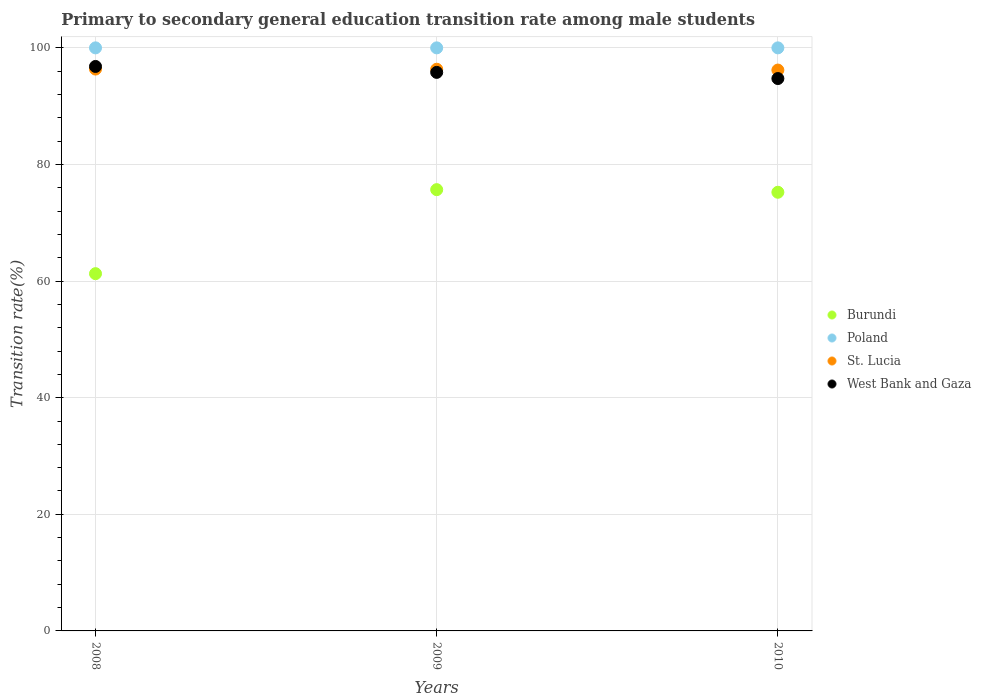Is the number of dotlines equal to the number of legend labels?
Your answer should be compact. Yes. What is the transition rate in West Bank and Gaza in 2008?
Offer a very short reply. 96.81. Across all years, what is the maximum transition rate in Burundi?
Offer a terse response. 75.68. Across all years, what is the minimum transition rate in Burundi?
Give a very brief answer. 61.27. In which year was the transition rate in Burundi minimum?
Offer a terse response. 2008. What is the total transition rate in Burundi in the graph?
Give a very brief answer. 212.19. What is the difference between the transition rate in Burundi in 2008 and that in 2009?
Provide a short and direct response. -14.41. What is the difference between the transition rate in West Bank and Gaza in 2008 and the transition rate in St. Lucia in 2009?
Your answer should be compact. 0.48. What is the average transition rate in St. Lucia per year?
Provide a succinct answer. 96.3. In the year 2008, what is the difference between the transition rate in St. Lucia and transition rate in Burundi?
Make the answer very short. 35.09. In how many years, is the transition rate in St. Lucia greater than 60 %?
Ensure brevity in your answer.  3. What is the ratio of the transition rate in St. Lucia in 2008 to that in 2010?
Provide a succinct answer. 1. Is the difference between the transition rate in St. Lucia in 2008 and 2010 greater than the difference between the transition rate in Burundi in 2008 and 2010?
Provide a succinct answer. Yes. What is the difference between the highest and the second highest transition rate in St. Lucia?
Your answer should be very brief. 0.03. What is the difference between the highest and the lowest transition rate in Poland?
Provide a short and direct response. 0. In how many years, is the transition rate in West Bank and Gaza greater than the average transition rate in West Bank and Gaza taken over all years?
Offer a very short reply. 2. Is it the case that in every year, the sum of the transition rate in Burundi and transition rate in Poland  is greater than the sum of transition rate in West Bank and Gaza and transition rate in St. Lucia?
Keep it short and to the point. Yes. Does the graph contain any zero values?
Your answer should be compact. No. Does the graph contain grids?
Ensure brevity in your answer.  Yes. How many legend labels are there?
Your response must be concise. 4. What is the title of the graph?
Your answer should be very brief. Primary to secondary general education transition rate among male students. Does "Paraguay" appear as one of the legend labels in the graph?
Give a very brief answer. No. What is the label or title of the Y-axis?
Provide a succinct answer. Transition rate(%). What is the Transition rate(%) in Burundi in 2008?
Provide a short and direct response. 61.27. What is the Transition rate(%) of Poland in 2008?
Ensure brevity in your answer.  100. What is the Transition rate(%) in St. Lucia in 2008?
Provide a short and direct response. 96.37. What is the Transition rate(%) of West Bank and Gaza in 2008?
Your answer should be compact. 96.81. What is the Transition rate(%) in Burundi in 2009?
Your answer should be very brief. 75.68. What is the Transition rate(%) in Poland in 2009?
Provide a succinct answer. 100. What is the Transition rate(%) of St. Lucia in 2009?
Your answer should be compact. 96.33. What is the Transition rate(%) of West Bank and Gaza in 2009?
Provide a short and direct response. 95.8. What is the Transition rate(%) of Burundi in 2010?
Keep it short and to the point. 75.24. What is the Transition rate(%) in St. Lucia in 2010?
Keep it short and to the point. 96.19. What is the Transition rate(%) of West Bank and Gaza in 2010?
Keep it short and to the point. 94.74. Across all years, what is the maximum Transition rate(%) in Burundi?
Provide a short and direct response. 75.68. Across all years, what is the maximum Transition rate(%) of St. Lucia?
Your answer should be compact. 96.37. Across all years, what is the maximum Transition rate(%) of West Bank and Gaza?
Give a very brief answer. 96.81. Across all years, what is the minimum Transition rate(%) of Burundi?
Offer a very short reply. 61.27. Across all years, what is the minimum Transition rate(%) in St. Lucia?
Your response must be concise. 96.19. Across all years, what is the minimum Transition rate(%) in West Bank and Gaza?
Make the answer very short. 94.74. What is the total Transition rate(%) in Burundi in the graph?
Your answer should be compact. 212.19. What is the total Transition rate(%) in Poland in the graph?
Offer a very short reply. 300. What is the total Transition rate(%) in St. Lucia in the graph?
Ensure brevity in your answer.  288.89. What is the total Transition rate(%) in West Bank and Gaza in the graph?
Your answer should be compact. 287.34. What is the difference between the Transition rate(%) of Burundi in 2008 and that in 2009?
Your response must be concise. -14.41. What is the difference between the Transition rate(%) in St. Lucia in 2008 and that in 2009?
Provide a succinct answer. 0.03. What is the difference between the Transition rate(%) of West Bank and Gaza in 2008 and that in 2009?
Provide a short and direct response. 1.02. What is the difference between the Transition rate(%) of Burundi in 2008 and that in 2010?
Offer a very short reply. -13.96. What is the difference between the Transition rate(%) of St. Lucia in 2008 and that in 2010?
Your response must be concise. 0.17. What is the difference between the Transition rate(%) of West Bank and Gaza in 2008 and that in 2010?
Your response must be concise. 2.07. What is the difference between the Transition rate(%) of Burundi in 2009 and that in 2010?
Offer a terse response. 0.45. What is the difference between the Transition rate(%) of St. Lucia in 2009 and that in 2010?
Make the answer very short. 0.14. What is the difference between the Transition rate(%) of West Bank and Gaza in 2009 and that in 2010?
Provide a short and direct response. 1.06. What is the difference between the Transition rate(%) of Burundi in 2008 and the Transition rate(%) of Poland in 2009?
Provide a short and direct response. -38.73. What is the difference between the Transition rate(%) of Burundi in 2008 and the Transition rate(%) of St. Lucia in 2009?
Keep it short and to the point. -35.06. What is the difference between the Transition rate(%) in Burundi in 2008 and the Transition rate(%) in West Bank and Gaza in 2009?
Provide a short and direct response. -34.52. What is the difference between the Transition rate(%) of Poland in 2008 and the Transition rate(%) of St. Lucia in 2009?
Offer a terse response. 3.67. What is the difference between the Transition rate(%) in Poland in 2008 and the Transition rate(%) in West Bank and Gaza in 2009?
Provide a succinct answer. 4.2. What is the difference between the Transition rate(%) of St. Lucia in 2008 and the Transition rate(%) of West Bank and Gaza in 2009?
Your answer should be very brief. 0.57. What is the difference between the Transition rate(%) in Burundi in 2008 and the Transition rate(%) in Poland in 2010?
Keep it short and to the point. -38.73. What is the difference between the Transition rate(%) of Burundi in 2008 and the Transition rate(%) of St. Lucia in 2010?
Offer a very short reply. -34.92. What is the difference between the Transition rate(%) of Burundi in 2008 and the Transition rate(%) of West Bank and Gaza in 2010?
Make the answer very short. -33.46. What is the difference between the Transition rate(%) of Poland in 2008 and the Transition rate(%) of St. Lucia in 2010?
Your answer should be very brief. 3.81. What is the difference between the Transition rate(%) of Poland in 2008 and the Transition rate(%) of West Bank and Gaza in 2010?
Give a very brief answer. 5.26. What is the difference between the Transition rate(%) in St. Lucia in 2008 and the Transition rate(%) in West Bank and Gaza in 2010?
Provide a short and direct response. 1.63. What is the difference between the Transition rate(%) in Burundi in 2009 and the Transition rate(%) in Poland in 2010?
Your response must be concise. -24.32. What is the difference between the Transition rate(%) of Burundi in 2009 and the Transition rate(%) of St. Lucia in 2010?
Provide a short and direct response. -20.51. What is the difference between the Transition rate(%) of Burundi in 2009 and the Transition rate(%) of West Bank and Gaza in 2010?
Keep it short and to the point. -19.06. What is the difference between the Transition rate(%) in Poland in 2009 and the Transition rate(%) in St. Lucia in 2010?
Ensure brevity in your answer.  3.81. What is the difference between the Transition rate(%) in Poland in 2009 and the Transition rate(%) in West Bank and Gaza in 2010?
Ensure brevity in your answer.  5.26. What is the difference between the Transition rate(%) in St. Lucia in 2009 and the Transition rate(%) in West Bank and Gaza in 2010?
Your response must be concise. 1.6. What is the average Transition rate(%) in Burundi per year?
Offer a very short reply. 70.73. What is the average Transition rate(%) in Poland per year?
Your response must be concise. 100. What is the average Transition rate(%) in St. Lucia per year?
Offer a very short reply. 96.3. What is the average Transition rate(%) of West Bank and Gaza per year?
Your answer should be very brief. 95.78. In the year 2008, what is the difference between the Transition rate(%) of Burundi and Transition rate(%) of Poland?
Your answer should be compact. -38.73. In the year 2008, what is the difference between the Transition rate(%) in Burundi and Transition rate(%) in St. Lucia?
Offer a terse response. -35.09. In the year 2008, what is the difference between the Transition rate(%) in Burundi and Transition rate(%) in West Bank and Gaza?
Your response must be concise. -35.54. In the year 2008, what is the difference between the Transition rate(%) of Poland and Transition rate(%) of St. Lucia?
Your response must be concise. 3.63. In the year 2008, what is the difference between the Transition rate(%) in Poland and Transition rate(%) in West Bank and Gaza?
Make the answer very short. 3.19. In the year 2008, what is the difference between the Transition rate(%) of St. Lucia and Transition rate(%) of West Bank and Gaza?
Provide a succinct answer. -0.45. In the year 2009, what is the difference between the Transition rate(%) in Burundi and Transition rate(%) in Poland?
Offer a terse response. -24.32. In the year 2009, what is the difference between the Transition rate(%) in Burundi and Transition rate(%) in St. Lucia?
Offer a very short reply. -20.65. In the year 2009, what is the difference between the Transition rate(%) of Burundi and Transition rate(%) of West Bank and Gaza?
Your response must be concise. -20.11. In the year 2009, what is the difference between the Transition rate(%) in Poland and Transition rate(%) in St. Lucia?
Make the answer very short. 3.67. In the year 2009, what is the difference between the Transition rate(%) of Poland and Transition rate(%) of West Bank and Gaza?
Provide a succinct answer. 4.2. In the year 2009, what is the difference between the Transition rate(%) in St. Lucia and Transition rate(%) in West Bank and Gaza?
Make the answer very short. 0.54. In the year 2010, what is the difference between the Transition rate(%) in Burundi and Transition rate(%) in Poland?
Provide a succinct answer. -24.76. In the year 2010, what is the difference between the Transition rate(%) in Burundi and Transition rate(%) in St. Lucia?
Give a very brief answer. -20.96. In the year 2010, what is the difference between the Transition rate(%) of Burundi and Transition rate(%) of West Bank and Gaza?
Ensure brevity in your answer.  -19.5. In the year 2010, what is the difference between the Transition rate(%) in Poland and Transition rate(%) in St. Lucia?
Provide a succinct answer. 3.81. In the year 2010, what is the difference between the Transition rate(%) in Poland and Transition rate(%) in West Bank and Gaza?
Offer a terse response. 5.26. In the year 2010, what is the difference between the Transition rate(%) in St. Lucia and Transition rate(%) in West Bank and Gaza?
Offer a very short reply. 1.46. What is the ratio of the Transition rate(%) in Burundi in 2008 to that in 2009?
Make the answer very short. 0.81. What is the ratio of the Transition rate(%) of Poland in 2008 to that in 2009?
Make the answer very short. 1. What is the ratio of the Transition rate(%) in St. Lucia in 2008 to that in 2009?
Ensure brevity in your answer.  1. What is the ratio of the Transition rate(%) of West Bank and Gaza in 2008 to that in 2009?
Provide a short and direct response. 1.01. What is the ratio of the Transition rate(%) in Burundi in 2008 to that in 2010?
Offer a very short reply. 0.81. What is the ratio of the Transition rate(%) in West Bank and Gaza in 2008 to that in 2010?
Offer a terse response. 1.02. What is the ratio of the Transition rate(%) in Burundi in 2009 to that in 2010?
Your answer should be very brief. 1.01. What is the ratio of the Transition rate(%) in West Bank and Gaza in 2009 to that in 2010?
Keep it short and to the point. 1.01. What is the difference between the highest and the second highest Transition rate(%) of Burundi?
Make the answer very short. 0.45. What is the difference between the highest and the second highest Transition rate(%) of St. Lucia?
Provide a succinct answer. 0.03. What is the difference between the highest and the second highest Transition rate(%) of West Bank and Gaza?
Offer a terse response. 1.02. What is the difference between the highest and the lowest Transition rate(%) of Burundi?
Make the answer very short. 14.41. What is the difference between the highest and the lowest Transition rate(%) in Poland?
Provide a succinct answer. 0. What is the difference between the highest and the lowest Transition rate(%) of St. Lucia?
Keep it short and to the point. 0.17. What is the difference between the highest and the lowest Transition rate(%) of West Bank and Gaza?
Your answer should be very brief. 2.07. 